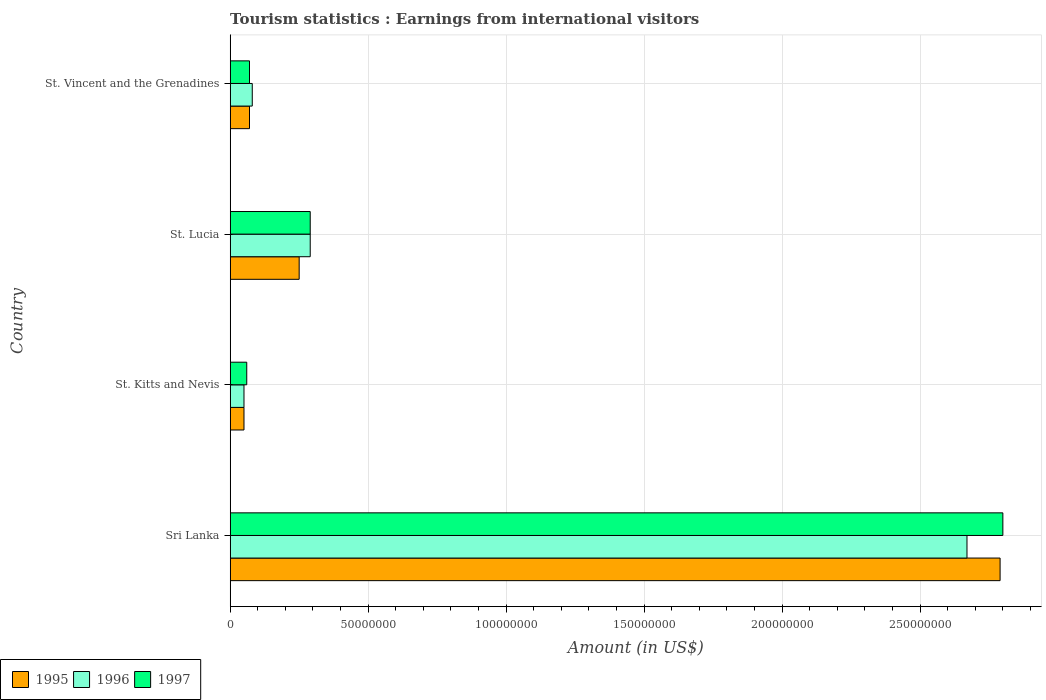How many different coloured bars are there?
Offer a very short reply. 3. How many groups of bars are there?
Make the answer very short. 4. Are the number of bars per tick equal to the number of legend labels?
Your answer should be compact. Yes. How many bars are there on the 1st tick from the top?
Provide a succinct answer. 3. What is the label of the 4th group of bars from the top?
Give a very brief answer. Sri Lanka. What is the earnings from international visitors in 1997 in St. Kitts and Nevis?
Offer a terse response. 6.00e+06. Across all countries, what is the maximum earnings from international visitors in 1996?
Provide a succinct answer. 2.67e+08. In which country was the earnings from international visitors in 1996 maximum?
Provide a short and direct response. Sri Lanka. In which country was the earnings from international visitors in 1995 minimum?
Your answer should be very brief. St. Kitts and Nevis. What is the total earnings from international visitors in 1997 in the graph?
Keep it short and to the point. 3.22e+08. What is the difference between the earnings from international visitors in 1995 in Sri Lanka and that in St. Kitts and Nevis?
Your response must be concise. 2.74e+08. What is the difference between the earnings from international visitors in 1996 in St. Vincent and the Grenadines and the earnings from international visitors in 1995 in St. Kitts and Nevis?
Make the answer very short. 3.00e+06. What is the average earnings from international visitors in 1996 per country?
Give a very brief answer. 7.72e+07. In how many countries, is the earnings from international visitors in 1995 greater than 240000000 US$?
Give a very brief answer. 1. What is the ratio of the earnings from international visitors in 1997 in St. Kitts and Nevis to that in St. Lucia?
Make the answer very short. 0.21. Is the difference between the earnings from international visitors in 1996 in St. Kitts and Nevis and St. Lucia greater than the difference between the earnings from international visitors in 1995 in St. Kitts and Nevis and St. Lucia?
Your answer should be very brief. No. What is the difference between the highest and the second highest earnings from international visitors in 1997?
Your response must be concise. 2.51e+08. What is the difference between the highest and the lowest earnings from international visitors in 1997?
Your answer should be very brief. 2.74e+08. In how many countries, is the earnings from international visitors in 1997 greater than the average earnings from international visitors in 1997 taken over all countries?
Your response must be concise. 1. Is the sum of the earnings from international visitors in 1995 in Sri Lanka and St. Vincent and the Grenadines greater than the maximum earnings from international visitors in 1996 across all countries?
Ensure brevity in your answer.  Yes. What does the 3rd bar from the top in St. Lucia represents?
Make the answer very short. 1995. What does the 1st bar from the bottom in St. Lucia represents?
Your response must be concise. 1995. Is it the case that in every country, the sum of the earnings from international visitors in 1997 and earnings from international visitors in 1995 is greater than the earnings from international visitors in 1996?
Your response must be concise. Yes. How many bars are there?
Make the answer very short. 12. Are all the bars in the graph horizontal?
Your answer should be very brief. Yes. Are the values on the major ticks of X-axis written in scientific E-notation?
Ensure brevity in your answer.  No. Does the graph contain any zero values?
Offer a very short reply. No. Where does the legend appear in the graph?
Offer a terse response. Bottom left. How are the legend labels stacked?
Your answer should be very brief. Horizontal. What is the title of the graph?
Offer a terse response. Tourism statistics : Earnings from international visitors. Does "1973" appear as one of the legend labels in the graph?
Offer a very short reply. No. What is the label or title of the X-axis?
Keep it short and to the point. Amount (in US$). What is the label or title of the Y-axis?
Provide a short and direct response. Country. What is the Amount (in US$) in 1995 in Sri Lanka?
Give a very brief answer. 2.79e+08. What is the Amount (in US$) of 1996 in Sri Lanka?
Provide a short and direct response. 2.67e+08. What is the Amount (in US$) of 1997 in Sri Lanka?
Offer a very short reply. 2.80e+08. What is the Amount (in US$) of 1995 in St. Kitts and Nevis?
Make the answer very short. 5.00e+06. What is the Amount (in US$) in 1996 in St. Kitts and Nevis?
Give a very brief answer. 5.00e+06. What is the Amount (in US$) of 1995 in St. Lucia?
Offer a very short reply. 2.50e+07. What is the Amount (in US$) in 1996 in St. Lucia?
Provide a succinct answer. 2.90e+07. What is the Amount (in US$) in 1997 in St. Lucia?
Keep it short and to the point. 2.90e+07. What is the Amount (in US$) in 1997 in St. Vincent and the Grenadines?
Offer a very short reply. 7.00e+06. Across all countries, what is the maximum Amount (in US$) of 1995?
Offer a very short reply. 2.79e+08. Across all countries, what is the maximum Amount (in US$) in 1996?
Give a very brief answer. 2.67e+08. Across all countries, what is the maximum Amount (in US$) in 1997?
Your response must be concise. 2.80e+08. Across all countries, what is the minimum Amount (in US$) in 1995?
Offer a terse response. 5.00e+06. What is the total Amount (in US$) in 1995 in the graph?
Offer a terse response. 3.16e+08. What is the total Amount (in US$) in 1996 in the graph?
Provide a short and direct response. 3.09e+08. What is the total Amount (in US$) of 1997 in the graph?
Ensure brevity in your answer.  3.22e+08. What is the difference between the Amount (in US$) of 1995 in Sri Lanka and that in St. Kitts and Nevis?
Your answer should be compact. 2.74e+08. What is the difference between the Amount (in US$) of 1996 in Sri Lanka and that in St. Kitts and Nevis?
Your answer should be very brief. 2.62e+08. What is the difference between the Amount (in US$) in 1997 in Sri Lanka and that in St. Kitts and Nevis?
Provide a succinct answer. 2.74e+08. What is the difference between the Amount (in US$) of 1995 in Sri Lanka and that in St. Lucia?
Your answer should be compact. 2.54e+08. What is the difference between the Amount (in US$) in 1996 in Sri Lanka and that in St. Lucia?
Offer a very short reply. 2.38e+08. What is the difference between the Amount (in US$) in 1997 in Sri Lanka and that in St. Lucia?
Offer a very short reply. 2.51e+08. What is the difference between the Amount (in US$) of 1995 in Sri Lanka and that in St. Vincent and the Grenadines?
Provide a short and direct response. 2.72e+08. What is the difference between the Amount (in US$) of 1996 in Sri Lanka and that in St. Vincent and the Grenadines?
Your answer should be compact. 2.59e+08. What is the difference between the Amount (in US$) in 1997 in Sri Lanka and that in St. Vincent and the Grenadines?
Provide a succinct answer. 2.73e+08. What is the difference between the Amount (in US$) of 1995 in St. Kitts and Nevis and that in St. Lucia?
Keep it short and to the point. -2.00e+07. What is the difference between the Amount (in US$) of 1996 in St. Kitts and Nevis and that in St. Lucia?
Give a very brief answer. -2.40e+07. What is the difference between the Amount (in US$) in 1997 in St. Kitts and Nevis and that in St. Lucia?
Your answer should be compact. -2.30e+07. What is the difference between the Amount (in US$) of 1995 in St. Lucia and that in St. Vincent and the Grenadines?
Give a very brief answer. 1.80e+07. What is the difference between the Amount (in US$) in 1996 in St. Lucia and that in St. Vincent and the Grenadines?
Provide a succinct answer. 2.10e+07. What is the difference between the Amount (in US$) in 1997 in St. Lucia and that in St. Vincent and the Grenadines?
Your response must be concise. 2.20e+07. What is the difference between the Amount (in US$) of 1995 in Sri Lanka and the Amount (in US$) of 1996 in St. Kitts and Nevis?
Keep it short and to the point. 2.74e+08. What is the difference between the Amount (in US$) in 1995 in Sri Lanka and the Amount (in US$) in 1997 in St. Kitts and Nevis?
Make the answer very short. 2.73e+08. What is the difference between the Amount (in US$) in 1996 in Sri Lanka and the Amount (in US$) in 1997 in St. Kitts and Nevis?
Offer a terse response. 2.61e+08. What is the difference between the Amount (in US$) in 1995 in Sri Lanka and the Amount (in US$) in 1996 in St. Lucia?
Provide a short and direct response. 2.50e+08. What is the difference between the Amount (in US$) of 1995 in Sri Lanka and the Amount (in US$) of 1997 in St. Lucia?
Offer a terse response. 2.50e+08. What is the difference between the Amount (in US$) of 1996 in Sri Lanka and the Amount (in US$) of 1997 in St. Lucia?
Give a very brief answer. 2.38e+08. What is the difference between the Amount (in US$) in 1995 in Sri Lanka and the Amount (in US$) in 1996 in St. Vincent and the Grenadines?
Make the answer very short. 2.71e+08. What is the difference between the Amount (in US$) of 1995 in Sri Lanka and the Amount (in US$) of 1997 in St. Vincent and the Grenadines?
Provide a short and direct response. 2.72e+08. What is the difference between the Amount (in US$) of 1996 in Sri Lanka and the Amount (in US$) of 1997 in St. Vincent and the Grenadines?
Offer a very short reply. 2.60e+08. What is the difference between the Amount (in US$) in 1995 in St. Kitts and Nevis and the Amount (in US$) in 1996 in St. Lucia?
Give a very brief answer. -2.40e+07. What is the difference between the Amount (in US$) of 1995 in St. Kitts and Nevis and the Amount (in US$) of 1997 in St. Lucia?
Give a very brief answer. -2.40e+07. What is the difference between the Amount (in US$) in 1996 in St. Kitts and Nevis and the Amount (in US$) in 1997 in St. Lucia?
Your response must be concise. -2.40e+07. What is the difference between the Amount (in US$) in 1995 in St. Lucia and the Amount (in US$) in 1996 in St. Vincent and the Grenadines?
Provide a short and direct response. 1.70e+07. What is the difference between the Amount (in US$) in 1995 in St. Lucia and the Amount (in US$) in 1997 in St. Vincent and the Grenadines?
Ensure brevity in your answer.  1.80e+07. What is the difference between the Amount (in US$) in 1996 in St. Lucia and the Amount (in US$) in 1997 in St. Vincent and the Grenadines?
Provide a succinct answer. 2.20e+07. What is the average Amount (in US$) of 1995 per country?
Give a very brief answer. 7.90e+07. What is the average Amount (in US$) in 1996 per country?
Your answer should be compact. 7.72e+07. What is the average Amount (in US$) of 1997 per country?
Ensure brevity in your answer.  8.05e+07. What is the difference between the Amount (in US$) of 1995 and Amount (in US$) of 1997 in Sri Lanka?
Your answer should be very brief. -1.00e+06. What is the difference between the Amount (in US$) of 1996 and Amount (in US$) of 1997 in Sri Lanka?
Keep it short and to the point. -1.30e+07. What is the difference between the Amount (in US$) of 1995 and Amount (in US$) of 1997 in St. Kitts and Nevis?
Offer a very short reply. -1.00e+06. What is the difference between the Amount (in US$) in 1995 and Amount (in US$) in 1996 in St. Lucia?
Give a very brief answer. -4.00e+06. What is the difference between the Amount (in US$) in 1995 and Amount (in US$) in 1996 in St. Vincent and the Grenadines?
Provide a short and direct response. -1.00e+06. What is the ratio of the Amount (in US$) of 1995 in Sri Lanka to that in St. Kitts and Nevis?
Give a very brief answer. 55.8. What is the ratio of the Amount (in US$) of 1996 in Sri Lanka to that in St. Kitts and Nevis?
Your answer should be compact. 53.4. What is the ratio of the Amount (in US$) of 1997 in Sri Lanka to that in St. Kitts and Nevis?
Offer a terse response. 46.67. What is the ratio of the Amount (in US$) of 1995 in Sri Lanka to that in St. Lucia?
Keep it short and to the point. 11.16. What is the ratio of the Amount (in US$) in 1996 in Sri Lanka to that in St. Lucia?
Give a very brief answer. 9.21. What is the ratio of the Amount (in US$) in 1997 in Sri Lanka to that in St. Lucia?
Provide a succinct answer. 9.66. What is the ratio of the Amount (in US$) in 1995 in Sri Lanka to that in St. Vincent and the Grenadines?
Keep it short and to the point. 39.86. What is the ratio of the Amount (in US$) of 1996 in Sri Lanka to that in St. Vincent and the Grenadines?
Give a very brief answer. 33.38. What is the ratio of the Amount (in US$) of 1997 in Sri Lanka to that in St. Vincent and the Grenadines?
Keep it short and to the point. 40. What is the ratio of the Amount (in US$) of 1995 in St. Kitts and Nevis to that in St. Lucia?
Your answer should be very brief. 0.2. What is the ratio of the Amount (in US$) of 1996 in St. Kitts and Nevis to that in St. Lucia?
Provide a short and direct response. 0.17. What is the ratio of the Amount (in US$) in 1997 in St. Kitts and Nevis to that in St. Lucia?
Give a very brief answer. 0.21. What is the ratio of the Amount (in US$) in 1996 in St. Kitts and Nevis to that in St. Vincent and the Grenadines?
Your response must be concise. 0.62. What is the ratio of the Amount (in US$) in 1997 in St. Kitts and Nevis to that in St. Vincent and the Grenadines?
Your answer should be very brief. 0.86. What is the ratio of the Amount (in US$) of 1995 in St. Lucia to that in St. Vincent and the Grenadines?
Your answer should be very brief. 3.57. What is the ratio of the Amount (in US$) of 1996 in St. Lucia to that in St. Vincent and the Grenadines?
Give a very brief answer. 3.62. What is the ratio of the Amount (in US$) of 1997 in St. Lucia to that in St. Vincent and the Grenadines?
Give a very brief answer. 4.14. What is the difference between the highest and the second highest Amount (in US$) of 1995?
Your answer should be compact. 2.54e+08. What is the difference between the highest and the second highest Amount (in US$) of 1996?
Give a very brief answer. 2.38e+08. What is the difference between the highest and the second highest Amount (in US$) of 1997?
Give a very brief answer. 2.51e+08. What is the difference between the highest and the lowest Amount (in US$) in 1995?
Ensure brevity in your answer.  2.74e+08. What is the difference between the highest and the lowest Amount (in US$) in 1996?
Provide a short and direct response. 2.62e+08. What is the difference between the highest and the lowest Amount (in US$) of 1997?
Your answer should be very brief. 2.74e+08. 